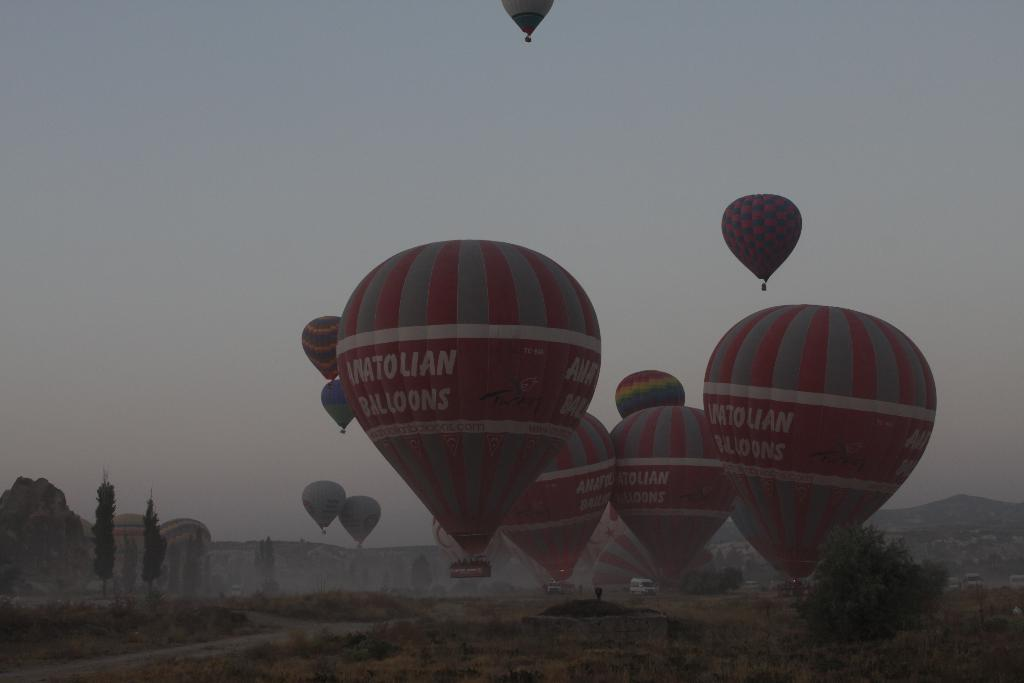What objects are visible in the image related to skydiving or parachuting? There are parachutes in the image. What can be seen in the background behind the parachutes? There are trees and vehicles behind the parachutes. What is visible at the top of the image? The sky is visible at the top of the image. Where is the shelf located in the image? There is no shelf present in the image. What type of straw is used to decorate the parachutes in the image? There are no straws present in the image, and the parachutes are not decorated with any straws. 